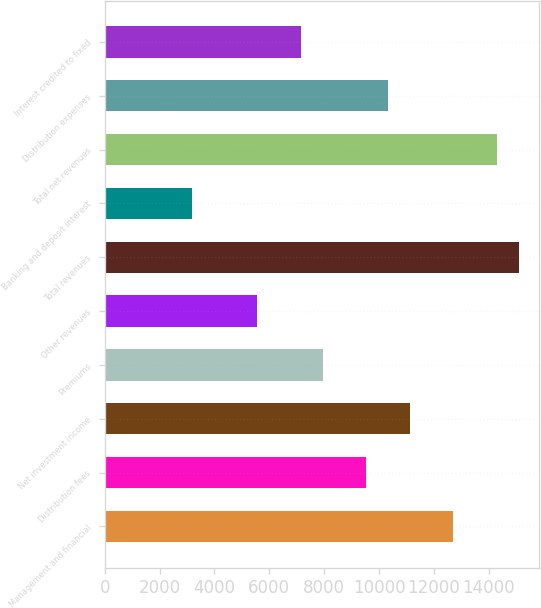Convert chart. <chart><loc_0><loc_0><loc_500><loc_500><bar_chart><fcel>Management and financial<fcel>Distribution fees<fcel>Net investment income<fcel>Premiums<fcel>Other revenues<fcel>Total revenues<fcel>Banking and deposit interest<fcel>Total net revenues<fcel>Distribution expenses<fcel>Interest credited to fixed<nl><fcel>12713.2<fcel>9535.04<fcel>11124.1<fcel>7945.98<fcel>5562.39<fcel>15096.8<fcel>3178.8<fcel>14302.2<fcel>10329.6<fcel>7151.45<nl></chart> 